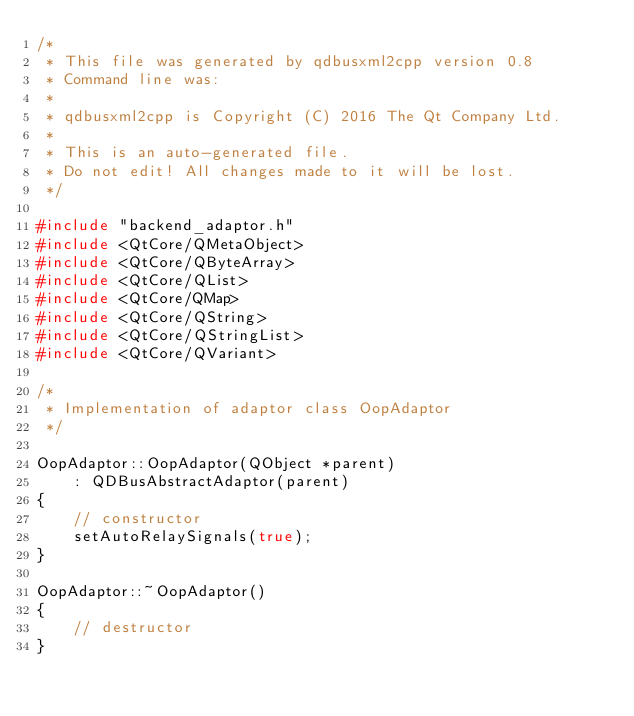<code> <loc_0><loc_0><loc_500><loc_500><_C++_>/*
 * This file was generated by qdbusxml2cpp version 0.8
 * Command line was: 
 *
 * qdbusxml2cpp is Copyright (C) 2016 The Qt Company Ltd.
 *
 * This is an auto-generated file.
 * Do not edit! All changes made to it will be lost.
 */

#include "backend_adaptor.h"
#include <QtCore/QMetaObject>
#include <QtCore/QByteArray>
#include <QtCore/QList>
#include <QtCore/QMap>
#include <QtCore/QString>
#include <QtCore/QStringList>
#include <QtCore/QVariant>

/*
 * Implementation of adaptor class OopAdaptor
 */

OopAdaptor::OopAdaptor(QObject *parent)
    : QDBusAbstractAdaptor(parent)
{
    // constructor
    setAutoRelaySignals(true);
}

OopAdaptor::~OopAdaptor()
{
    // destructor
}

</code> 